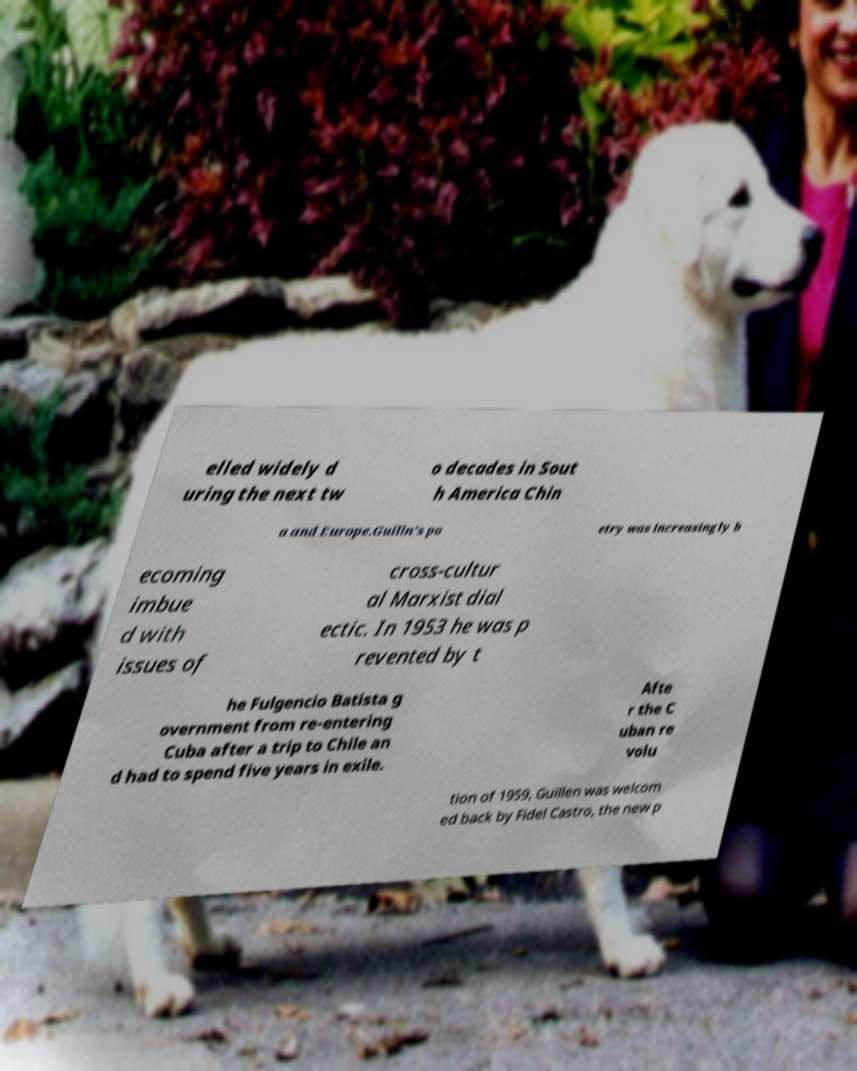Can you read and provide the text displayed in the image?This photo seems to have some interesting text. Can you extract and type it out for me? elled widely d uring the next tw o decades in Sout h America Chin a and Europe.Guilln's po etry was increasingly b ecoming imbue d with issues of cross-cultur al Marxist dial ectic. In 1953 he was p revented by t he Fulgencio Batista g overnment from re-entering Cuba after a trip to Chile an d had to spend five years in exile. Afte r the C uban re volu tion of 1959, Guillen was welcom ed back by Fidel Castro, the new p 